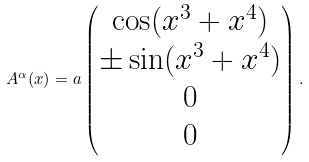Convert formula to latex. <formula><loc_0><loc_0><loc_500><loc_500>A ^ { \alpha } ( x ) = a \begin{pmatrix} \cos ( x ^ { 3 } + x ^ { 4 } ) \\ \pm \sin ( x ^ { 3 } + x ^ { 4 } ) \\ 0 \\ 0 \end{pmatrix} .</formula> 